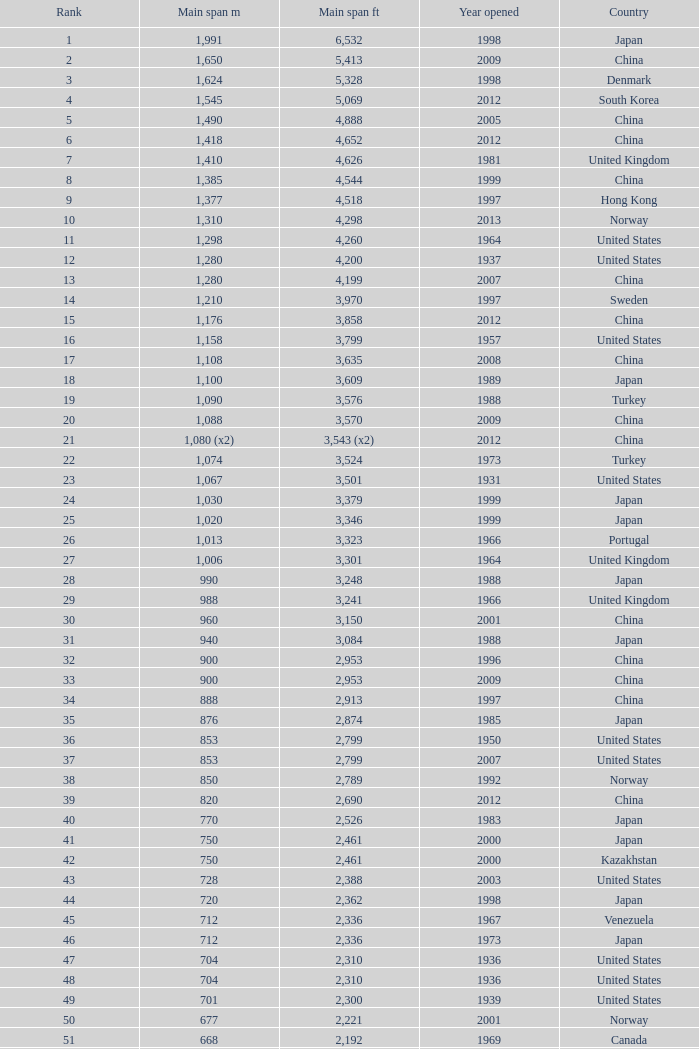What is the oldest year with a main span feet of 1,640 in South Korea? 2002.0. 